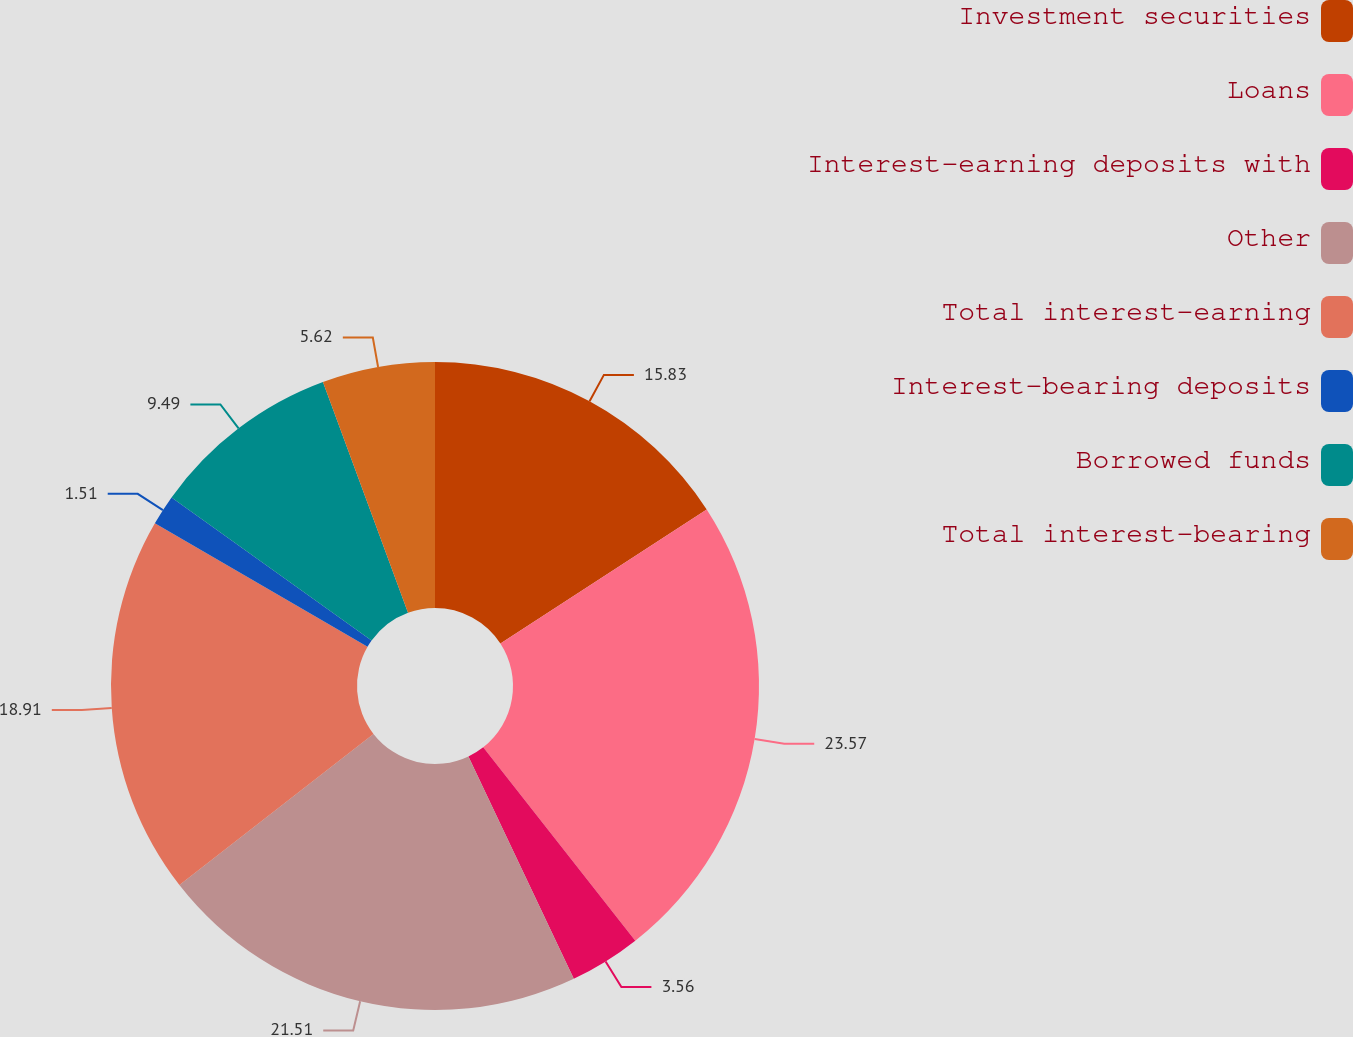Convert chart. <chart><loc_0><loc_0><loc_500><loc_500><pie_chart><fcel>Investment securities<fcel>Loans<fcel>Interest-earning deposits with<fcel>Other<fcel>Total interest-earning<fcel>Interest-bearing deposits<fcel>Borrowed funds<fcel>Total interest-bearing<nl><fcel>15.83%<fcel>23.56%<fcel>3.56%<fcel>21.51%<fcel>18.91%<fcel>1.51%<fcel>9.49%<fcel>5.62%<nl></chart> 